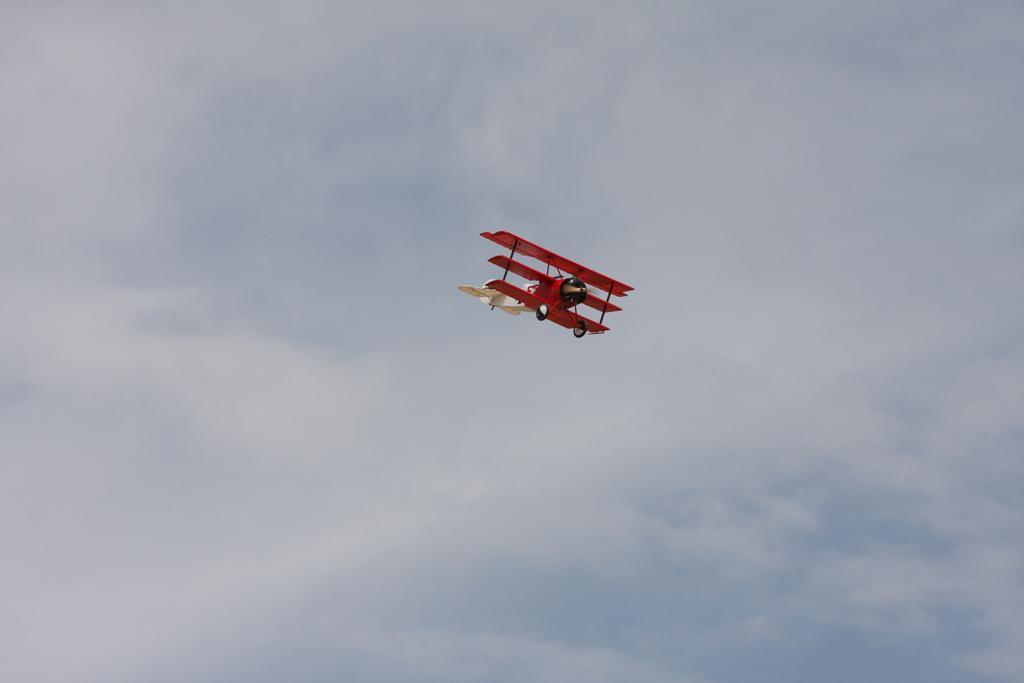How would you summarize this image in a sentence or two? In this image there is flight in the sky. 